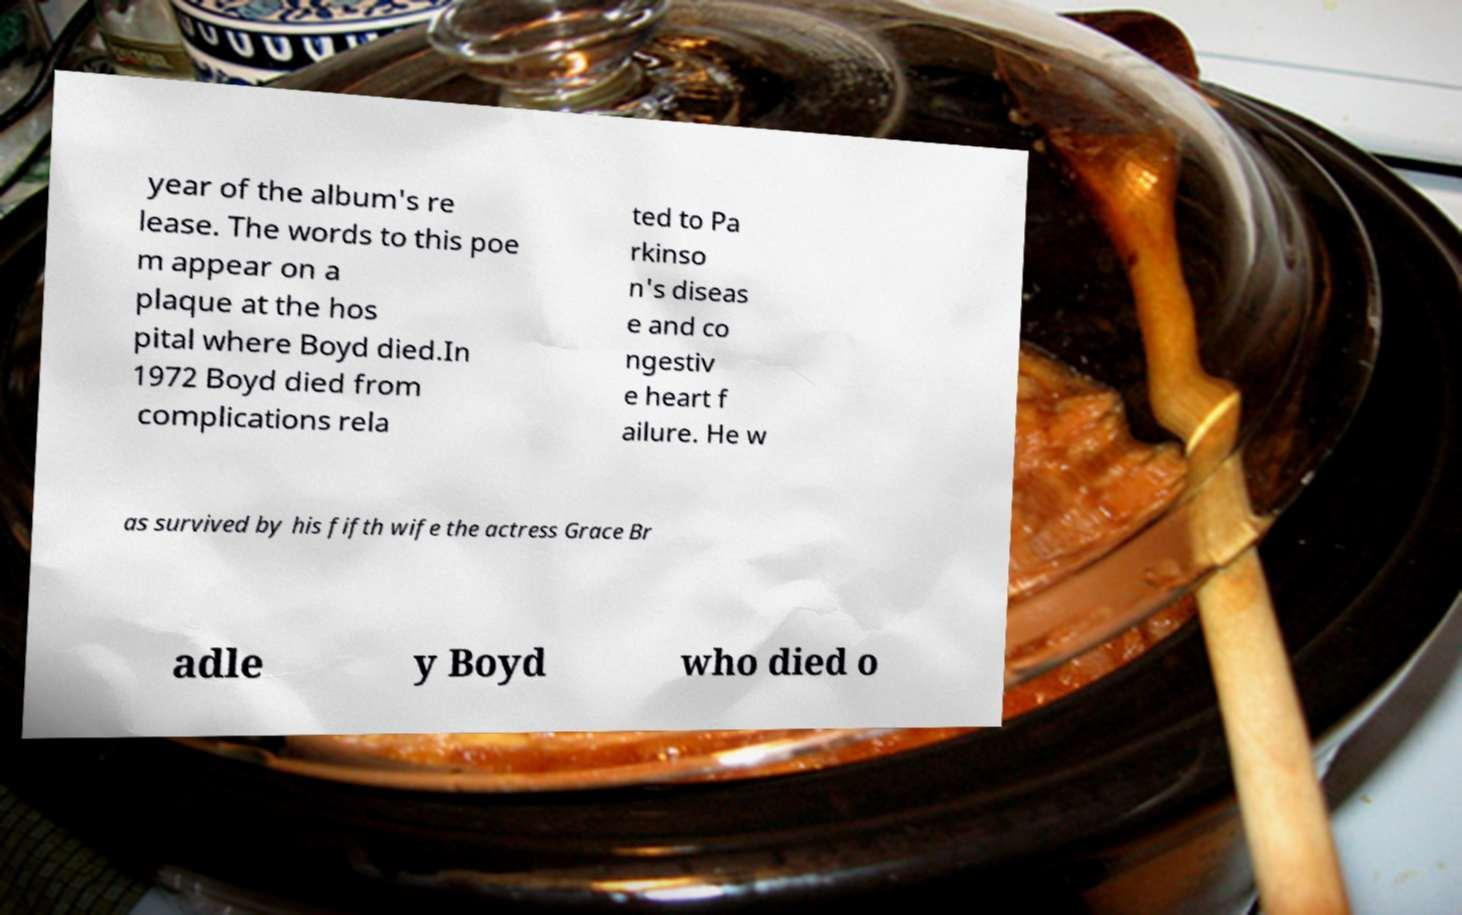Please identify and transcribe the text found in this image. year of the album's re lease. The words to this poe m appear on a plaque at the hos pital where Boyd died.In 1972 Boyd died from complications rela ted to Pa rkinso n's diseas e and co ngestiv e heart f ailure. He w as survived by his fifth wife the actress Grace Br adle y Boyd who died o 